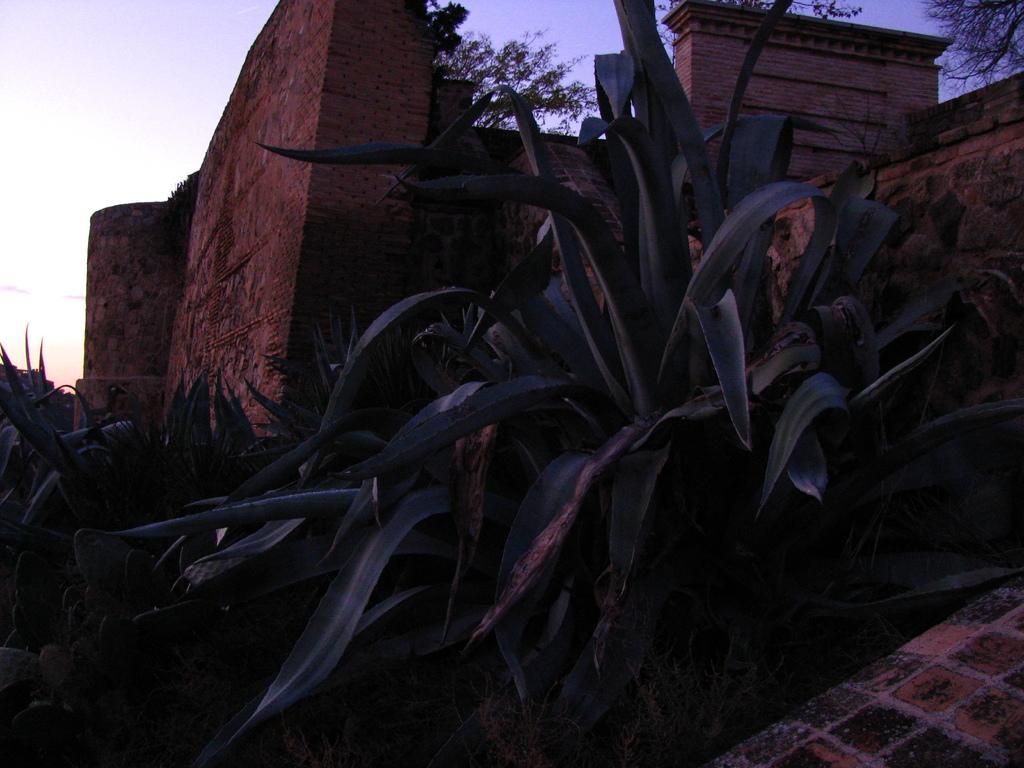In one or two sentences, can you explain what this image depicts? In this image i can see many plants in the foreground, in the middle we can see wall made of rocks and in the background we can see the sky. 